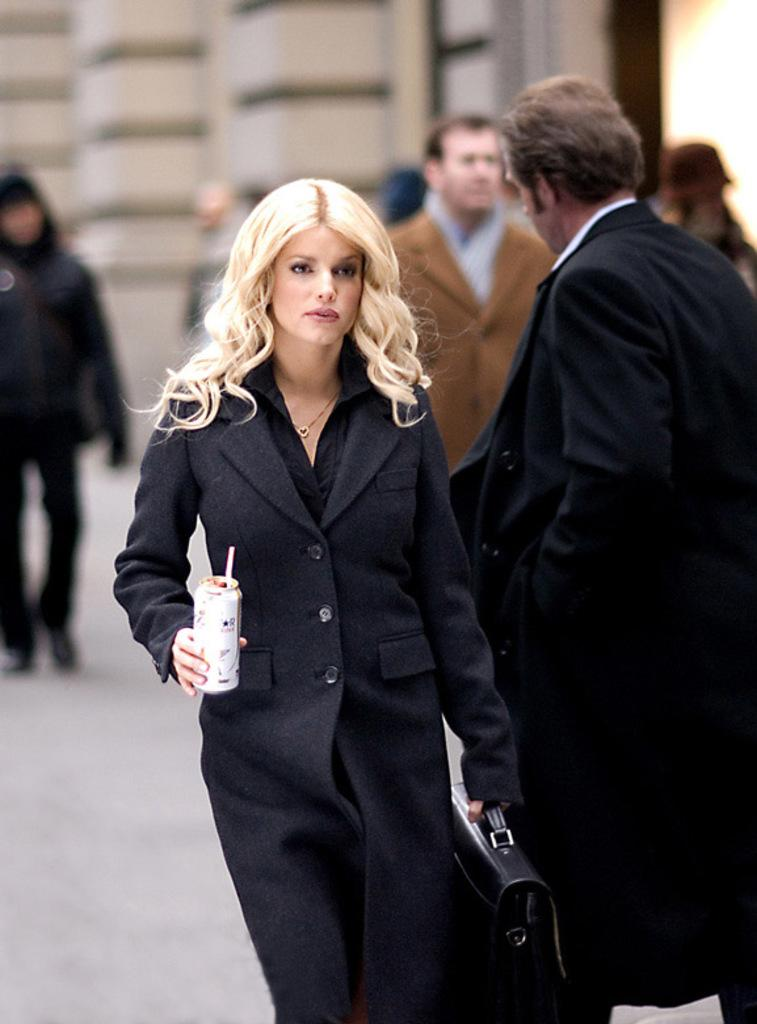What is happening in the image? There is a group of people in the image, and they are walking on a road. What can be seen beside the road in the image? There is a building beside the road in the image. What type of bushes can be seen growing on the moon in the image? There is no moon or bushes present in the image; it features a group of people walking on a road with a building beside it. 